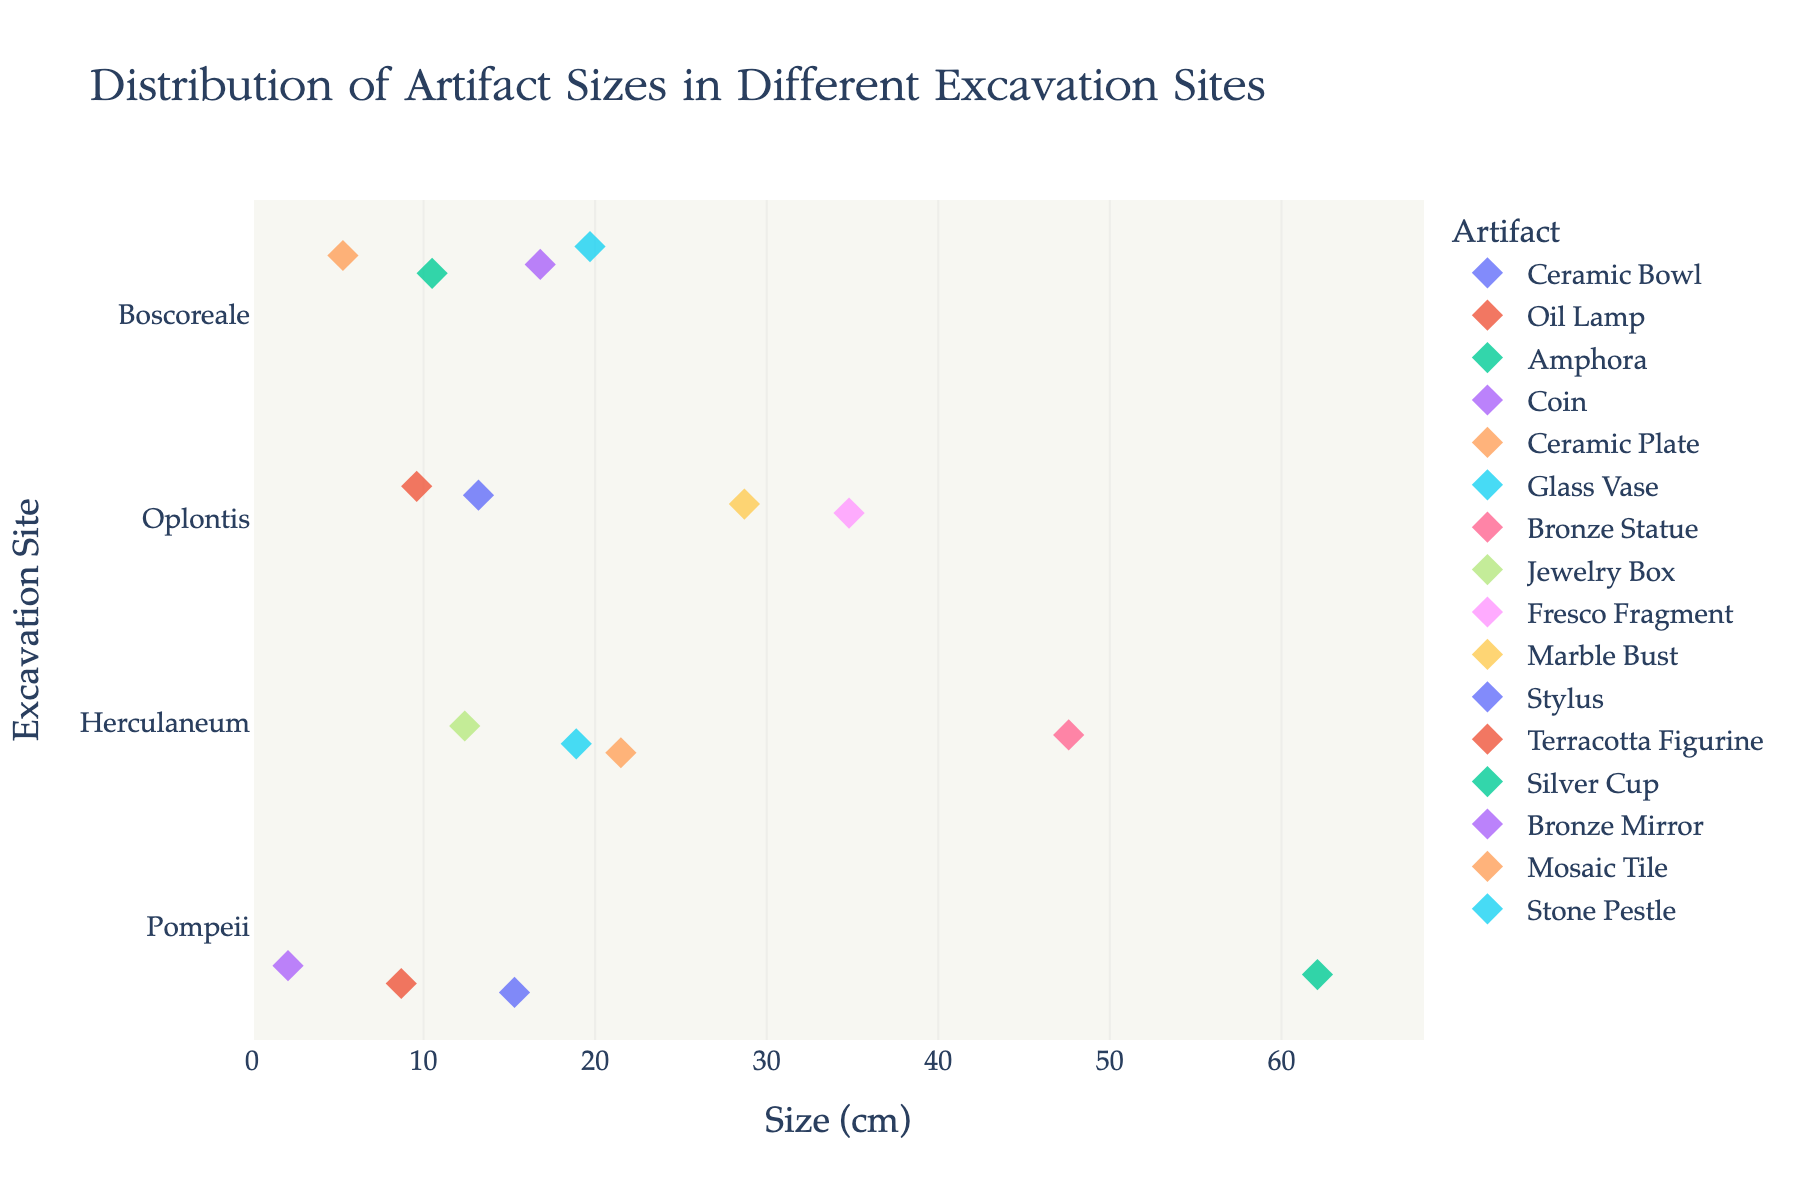what is the title of the plot? The title is situated at the top of the figure and describes the overall subject of the plot, which is the distribution of artifact sizes across different excavation sites.
Answer: Distribution of Artifact Sizes in Different Excavation Sites How many data points are displayed for each excavation site? Count the number of points representing artifacts for each site separately. Pompeii has 4, Herculaneum has 4, Oplontis has 4, and Boscoreale has 4. Therefore, each site has 4 data points.
Answer: 4 Which excavation site has the largest artifact size and what is it? Look for the diamond marker furthest to the right on the x-axis. The largest artifact is an "Amphora" from Pompeii, measuring 62.1 cm.
Answer: Pompeii, Amphora, 62.1 cm Compare the smallest artifact size from Pompeii and Boscoreale. Which one is smaller? Identify the smallest points on the x-axis for both sites. In Pompeii, the smallest artifact is a "Coin" at 2.1 cm, and in Boscoreale, it's a "Mosaic Tile" at 5.3 cm. The Coin from Pompeii is smaller.
Answer: Pompeii's Coin is smaller What is the average size of artifacts found at Boscoreale? Sum the sizes of artifacts from Boscoreale and divide by the number of artifacts. Sizes: 10.5, 16.8, 5.3, 19.7. Calculation: (10.5 + 16.8 + 5.3 + 19.7) / 4 = 52.3 / 4 = 13.1 cm.
Answer: 13.1 cm Which artifact in the plot has a size closest to 20 cm? Identify the diamond marker closest to the 20 cm mark on the x-axis. The closest artifact is the "Stone Pestle" from Boscoreale, which is 19.7 cm.
Answer: Stone Pestle from Boscoreale Which excavation site has the highest variety in artifact sizes? Look for the site with the widest spread of data points on the x-axis. Pompeii has artifacts ranging from 2.1 cm to 62.1 cm, the largest range compared to other sites.
Answer: Pompeii How does the size of the "Glass Vase" from Herculaneum compare to the average size of artifacts from Oplontis? The size of the "Glass Vase" is 18.9 cm. Calculate the average size for Oplontis: (34.8 + 28.7 + 13.2 + 9.6) / 4 = 21.575 cm. Compare: 18.9 cm < 21.575 cm.
Answer: Smaller Are there more artifacts larger than 20 cm in Pompeii or Herculaneum? Identify markers larger than 20 cm on the x-axis for each site: Pompeii has 1 ("Amphora" 62.1 cm), Herculaneum has 2 ("Ceramic Plate" 21.5 cm, "Bronze Statue" 47.6 cm). Herculaneum has more.
Answer: Herculaneum What is the largest artifact found in Oplontis? Look for the diamond marker furthest to the right in the Oplontis category on the y-axis. The largest artifact is the "Fresco Fragment" at 34.8 cm.
Answer: Fresco Fragment at 34.8 cm 